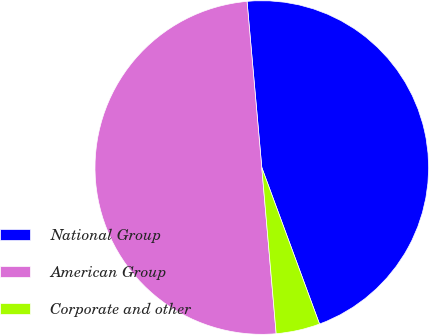Convert chart. <chart><loc_0><loc_0><loc_500><loc_500><pie_chart><fcel>National Group<fcel>American Group<fcel>Corporate and other<nl><fcel>45.78%<fcel>49.96%<fcel>4.25%<nl></chart> 